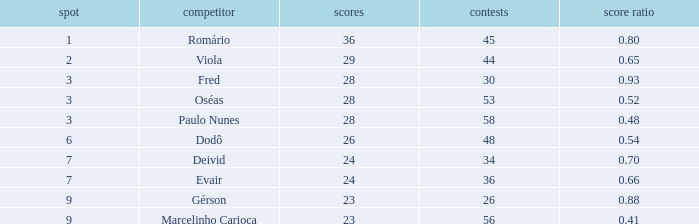How many games have 23 goals with a rank greater than 9? 0.0. 